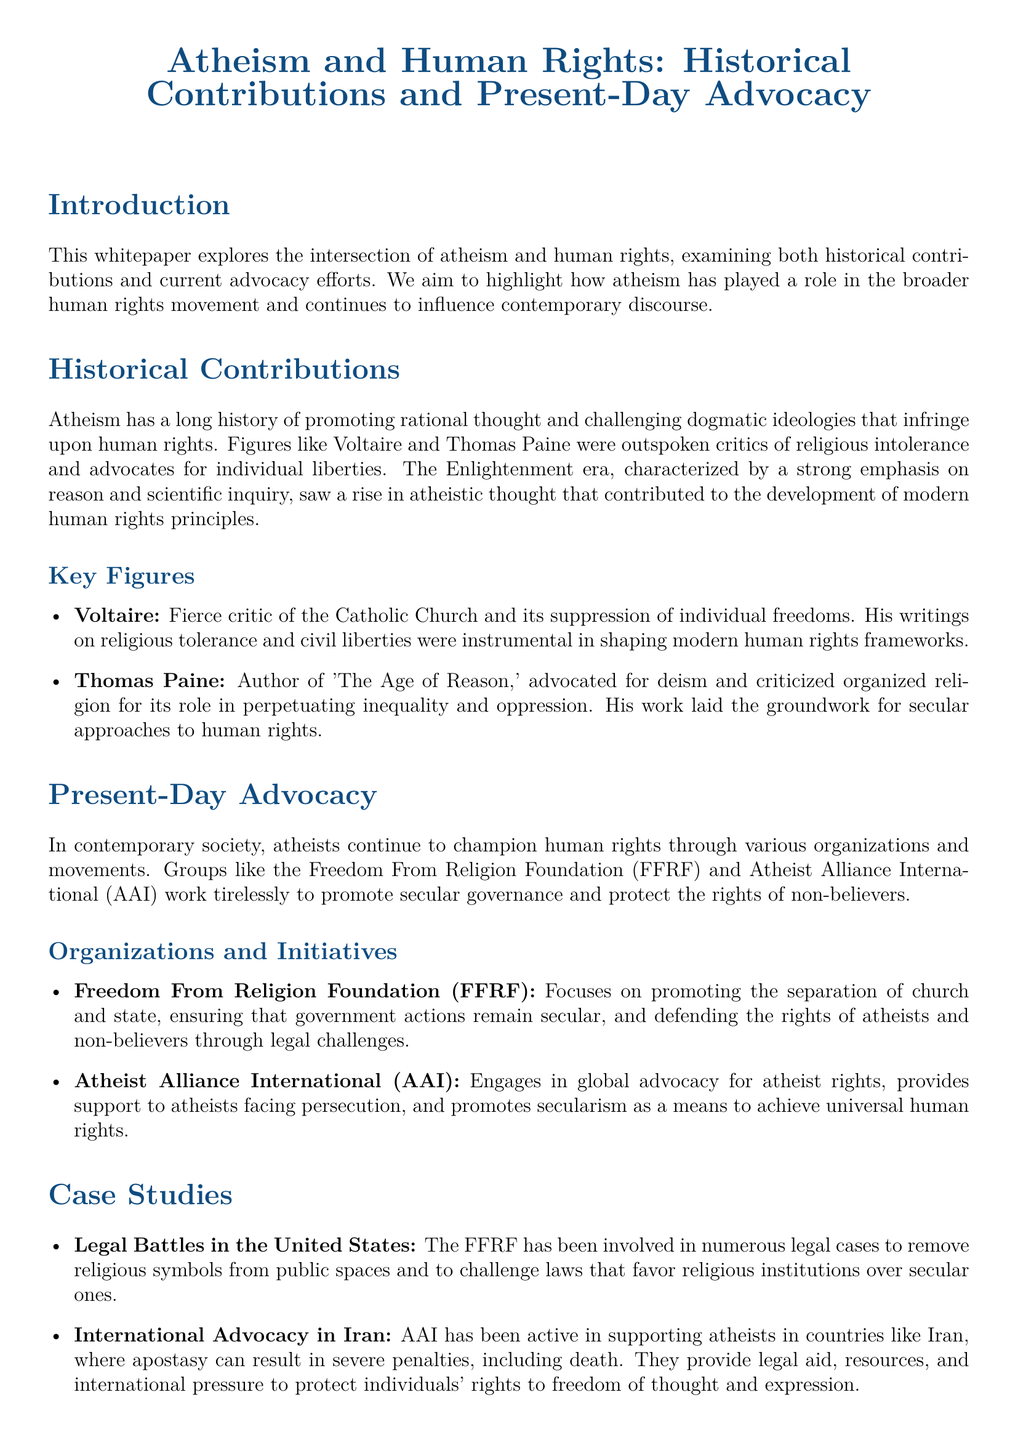What is the title of the whitepaper? The title is specified in the document's title section.
Answer: Atheism and Human Rights: Historical Contributions and Present-Day Advocacy Who were the key figures mentioned in the historical contributions section? The document lists significant individuals who contributed to human rights through atheism.
Answer: Voltaire and Thomas Paine What organization focuses on the separation of church and state? The document describes various organizations that advocate for human rights, specifying their focuses.
Answer: Freedom From Religion Foundation (FFRF) In which country does Atheist Alliance International support atheists facing persecution? The document provides specific examples of countries where advocacy is necessary.
Answer: Iran What is one of the legal battles mentioned that FFRF is involved in? The document discusses specific cases where the FFRF intervenes in legal matters concerning religion and state.
Answer: Removing religious symbols from public spaces How did atheism contribute to the Enlightenment era? The document explains the impact of atheism during the Enlightenment in terms of ideas and human rights.
Answer: Promoting rational thought and scientific inquiry What does AAI provide to support atheists? The document outlines the initiatives and support provided by Atheist Alliance International.
Answer: Legal aid and resources What are the universal principles that atheists advocate for? The document summarizes the key concepts that guide atheists in their advocacy for human rights.
Answer: Equality, freedom, and justice 